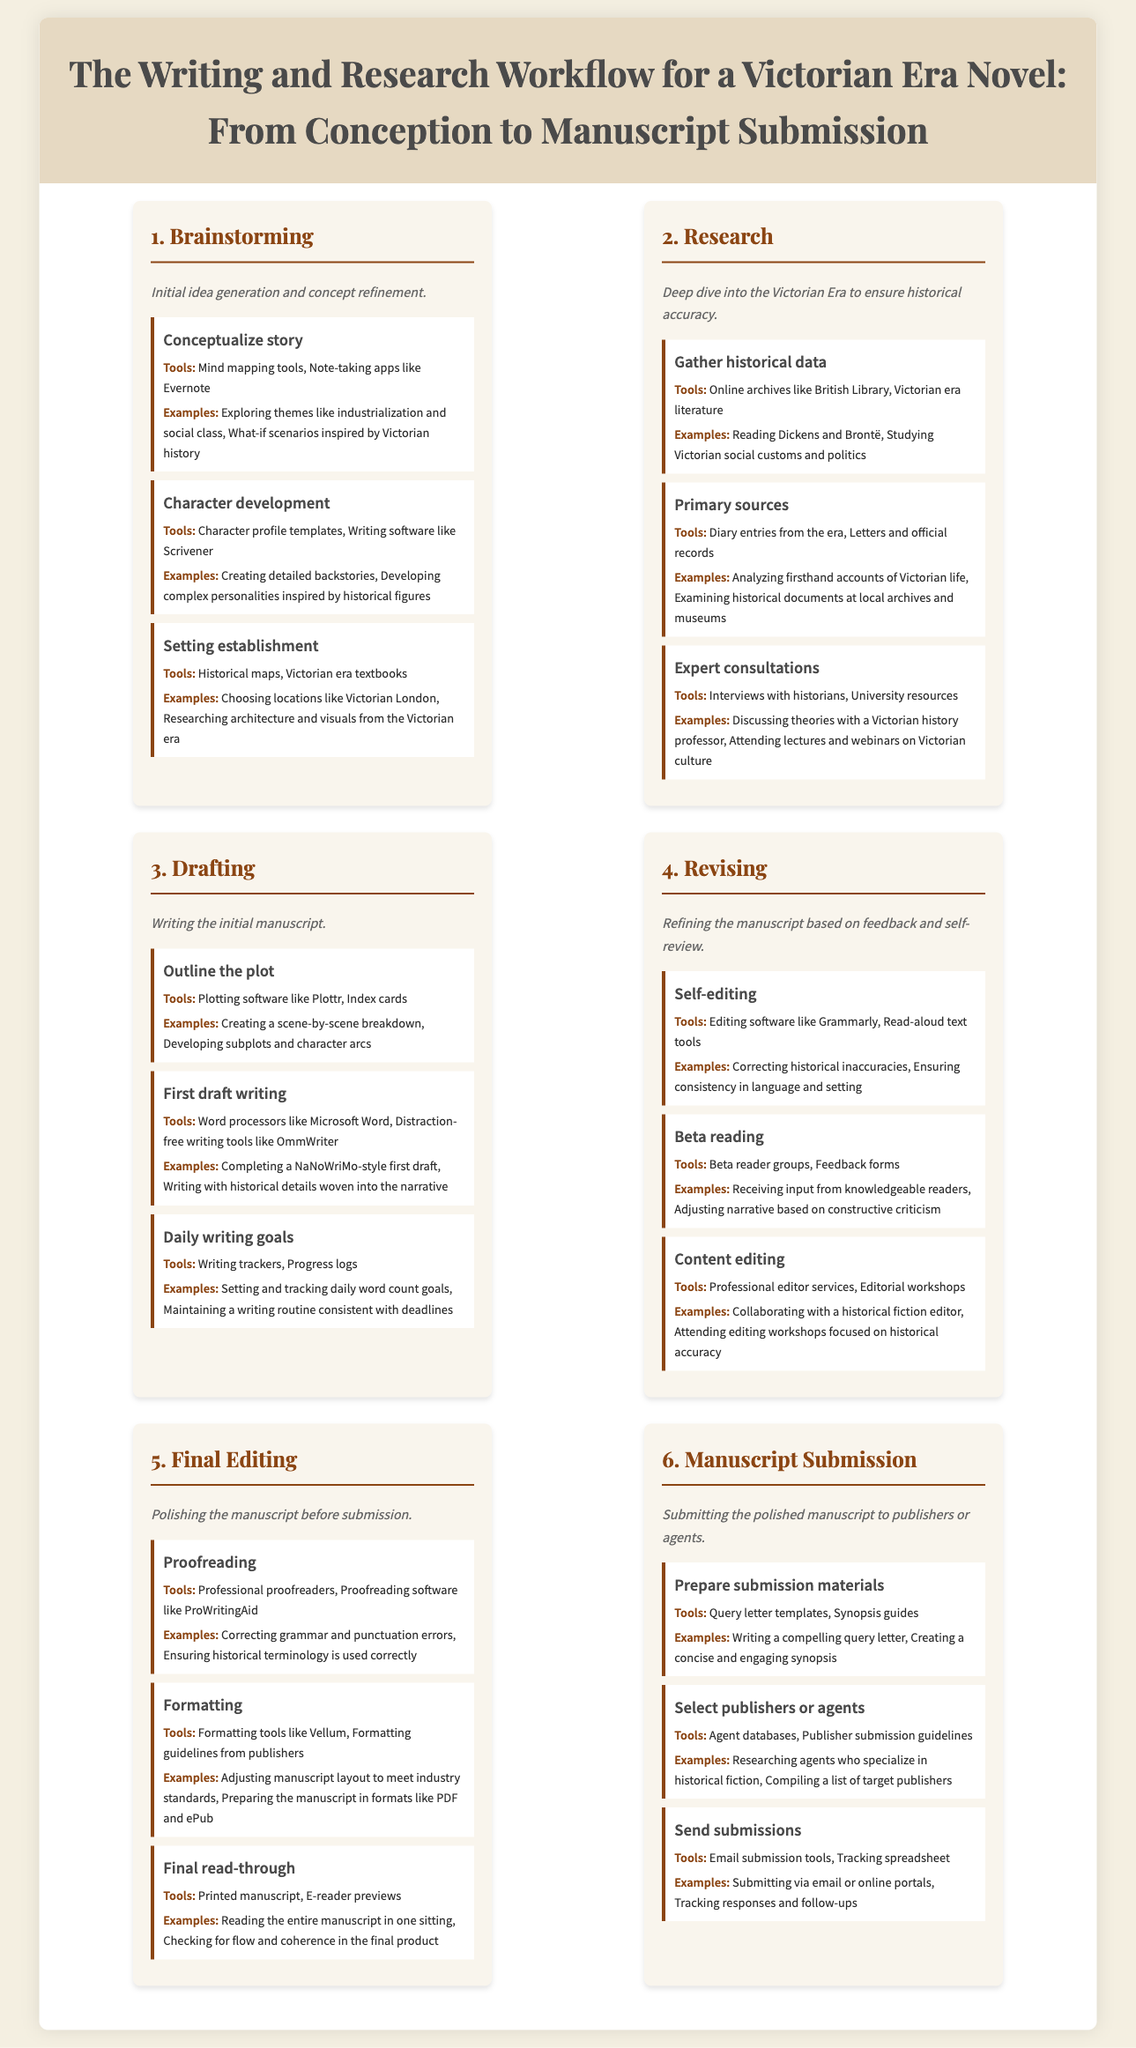what is the first stage of the writing workflow? The first stage of the workflow is the initial phase designed for idea generation and concept refinement.
Answer: Brainstorming what tools are suggested for character development? The document lists tools that help in creating character profiles and organizing writing tasks.
Answer: Character profile templates, Writing software like Scrivener which author is mentioned in the research step examples? The example lists notable authors whose works provide insights into the Victorian era.
Answer: Dickens how many main stages are included in the workflow? The document outlines the steps required to complete a Victorian era novel from start to submission.
Answer: Six what is the purpose of the final editing stage? This stage ensures that the manuscript is thoroughly assessed before it is sent to potential publishers or agents.
Answer: Polishing the manuscript what is included in the submission materials preparation? This step emphasizes the importance of producing compelling materials needed for manuscript submission.
Answer: Query letter templates, Synopsis guides what is the goal of beta reading? Beta reading involves gathering feedback from readers who can provide insights into the manuscript's effectiveness.
Answer: Receiving input from knowledgeable readers what is the last step in the manuscript process? This step marks the conclusion of the writing and editing process before an author can move forward with their work.
Answer: Manuscript Submission 